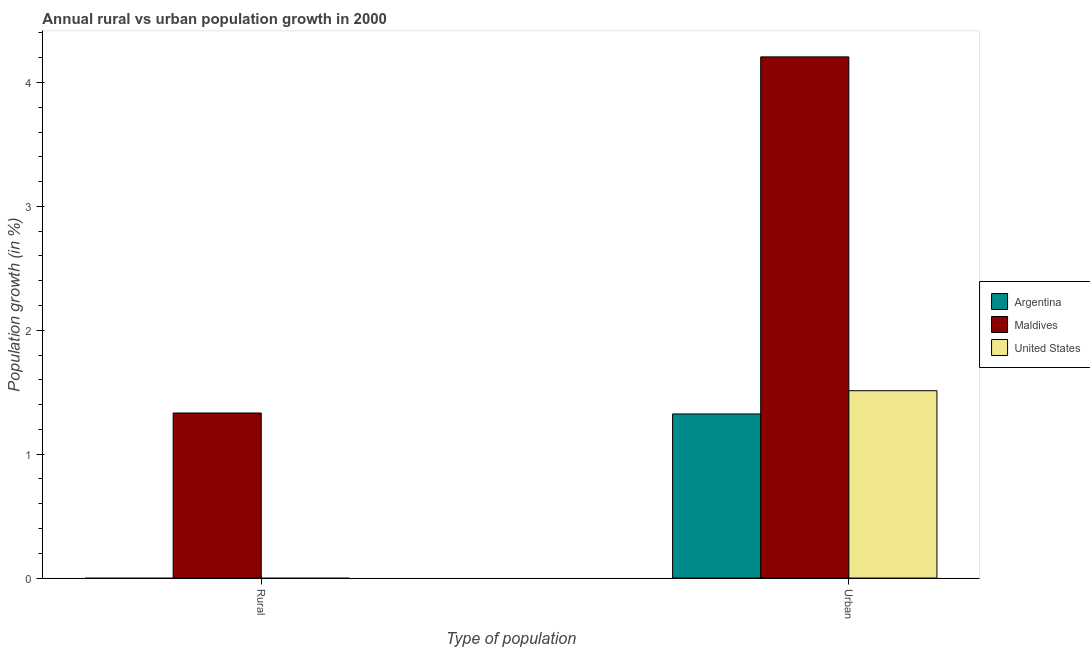How many different coloured bars are there?
Keep it short and to the point. 3. Are the number of bars per tick equal to the number of legend labels?
Your answer should be very brief. No. Are the number of bars on each tick of the X-axis equal?
Provide a succinct answer. No. How many bars are there on the 2nd tick from the left?
Provide a succinct answer. 3. How many bars are there on the 2nd tick from the right?
Offer a terse response. 1. What is the label of the 2nd group of bars from the left?
Keep it short and to the point. Urban . What is the urban population growth in Argentina?
Give a very brief answer. 1.32. Across all countries, what is the maximum rural population growth?
Offer a terse response. 1.33. Across all countries, what is the minimum urban population growth?
Your answer should be very brief. 1.32. In which country was the rural population growth maximum?
Give a very brief answer. Maldives. What is the total rural population growth in the graph?
Your answer should be very brief. 1.33. What is the difference between the urban population growth in United States and that in Argentina?
Keep it short and to the point. 0.19. What is the difference between the urban population growth in United States and the rural population growth in Argentina?
Give a very brief answer. 1.51. What is the average rural population growth per country?
Your response must be concise. 0.44. What is the difference between the urban population growth and rural population growth in Maldives?
Keep it short and to the point. 2.87. In how many countries, is the rural population growth greater than 4 %?
Keep it short and to the point. 0. What is the ratio of the urban population growth in United States to that in Maldives?
Provide a succinct answer. 0.36. Is the urban population growth in Argentina less than that in Maldives?
Give a very brief answer. Yes. What is the difference between two consecutive major ticks on the Y-axis?
Your response must be concise. 1. How are the legend labels stacked?
Offer a very short reply. Vertical. What is the title of the graph?
Provide a short and direct response. Annual rural vs urban population growth in 2000. What is the label or title of the X-axis?
Provide a succinct answer. Type of population. What is the label or title of the Y-axis?
Keep it short and to the point. Population growth (in %). What is the Population growth (in %) in Argentina in Rural?
Your answer should be compact. 0. What is the Population growth (in %) in Maldives in Rural?
Ensure brevity in your answer.  1.33. What is the Population growth (in %) in United States in Rural?
Your answer should be compact. 0. What is the Population growth (in %) of Argentina in Urban ?
Provide a succinct answer. 1.32. What is the Population growth (in %) in Maldives in Urban ?
Provide a succinct answer. 4.21. What is the Population growth (in %) of United States in Urban ?
Your response must be concise. 1.51. Across all Type of population, what is the maximum Population growth (in %) in Argentina?
Your answer should be very brief. 1.32. Across all Type of population, what is the maximum Population growth (in %) of Maldives?
Your response must be concise. 4.21. Across all Type of population, what is the maximum Population growth (in %) in United States?
Your answer should be compact. 1.51. Across all Type of population, what is the minimum Population growth (in %) in Maldives?
Provide a succinct answer. 1.33. What is the total Population growth (in %) in Argentina in the graph?
Keep it short and to the point. 1.32. What is the total Population growth (in %) in Maldives in the graph?
Offer a terse response. 5.54. What is the total Population growth (in %) in United States in the graph?
Your answer should be very brief. 1.51. What is the difference between the Population growth (in %) in Maldives in Rural and that in Urban ?
Provide a succinct answer. -2.87. What is the difference between the Population growth (in %) of Maldives in Rural and the Population growth (in %) of United States in Urban?
Keep it short and to the point. -0.18. What is the average Population growth (in %) of Argentina per Type of population?
Provide a succinct answer. 0.66. What is the average Population growth (in %) of Maldives per Type of population?
Offer a terse response. 2.77. What is the average Population growth (in %) in United States per Type of population?
Your answer should be compact. 0.76. What is the difference between the Population growth (in %) of Argentina and Population growth (in %) of Maldives in Urban ?
Provide a succinct answer. -2.88. What is the difference between the Population growth (in %) in Argentina and Population growth (in %) in United States in Urban ?
Your answer should be very brief. -0.19. What is the difference between the Population growth (in %) of Maldives and Population growth (in %) of United States in Urban ?
Provide a succinct answer. 2.69. What is the ratio of the Population growth (in %) of Maldives in Rural to that in Urban ?
Offer a very short reply. 0.32. What is the difference between the highest and the second highest Population growth (in %) in Maldives?
Keep it short and to the point. 2.87. What is the difference between the highest and the lowest Population growth (in %) in Argentina?
Give a very brief answer. 1.32. What is the difference between the highest and the lowest Population growth (in %) of Maldives?
Your response must be concise. 2.87. What is the difference between the highest and the lowest Population growth (in %) of United States?
Offer a very short reply. 1.51. 